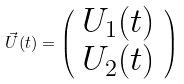Convert formula to latex. <formula><loc_0><loc_0><loc_500><loc_500>\vec { U } ( t ) = \left ( \begin{array} { l } U _ { 1 } ( t ) \\ U _ { 2 } ( t ) \end{array} \right )</formula> 